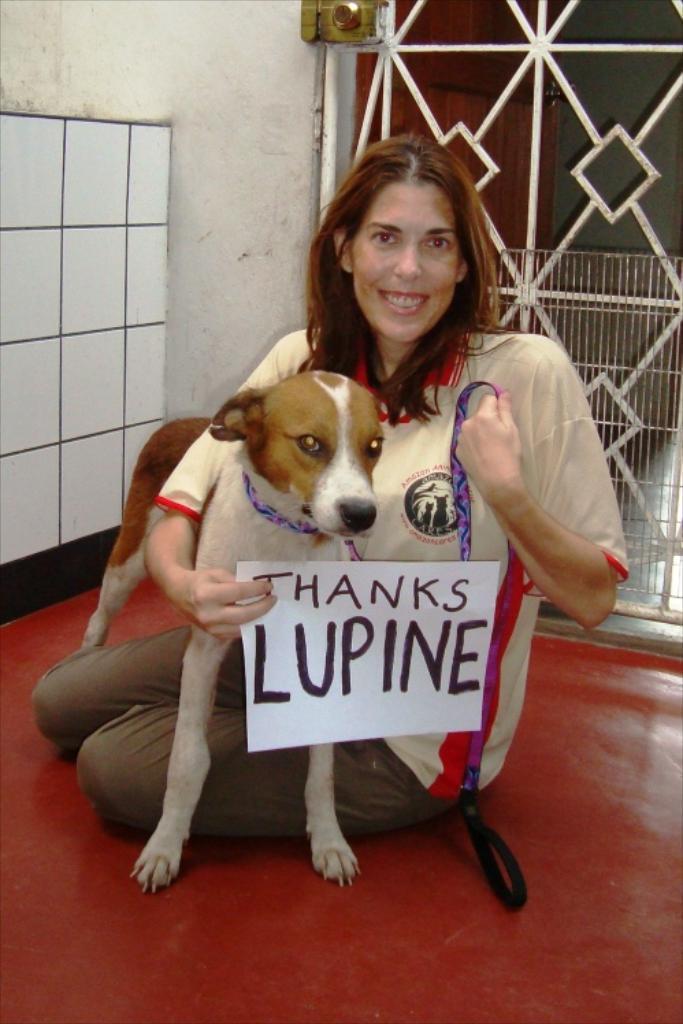In one or two sentences, can you explain what this image depicts? In this picture there is a woman holding a dog with a paper in her hand. 